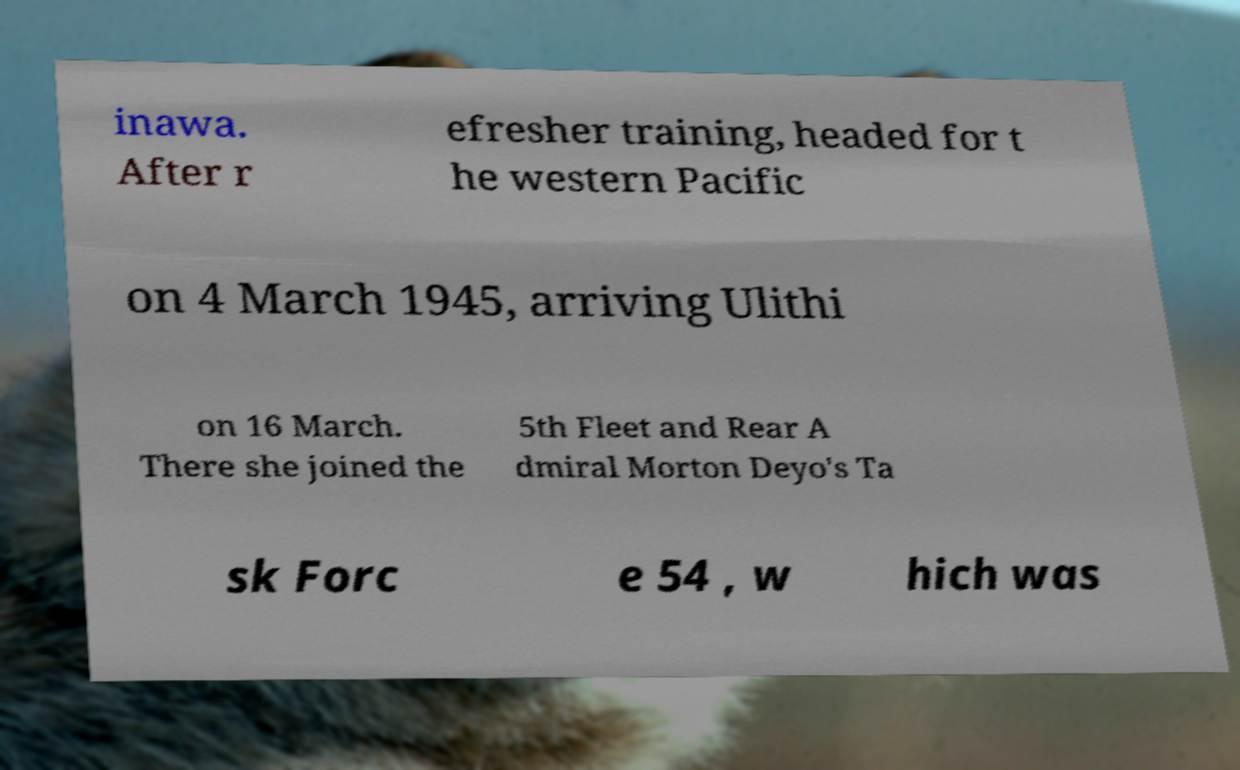For documentation purposes, I need the text within this image transcribed. Could you provide that? inawa. After r efresher training, headed for t he western Pacific on 4 March 1945, arriving Ulithi on 16 March. There she joined the 5th Fleet and Rear A dmiral Morton Deyo's Ta sk Forc e 54 , w hich was 